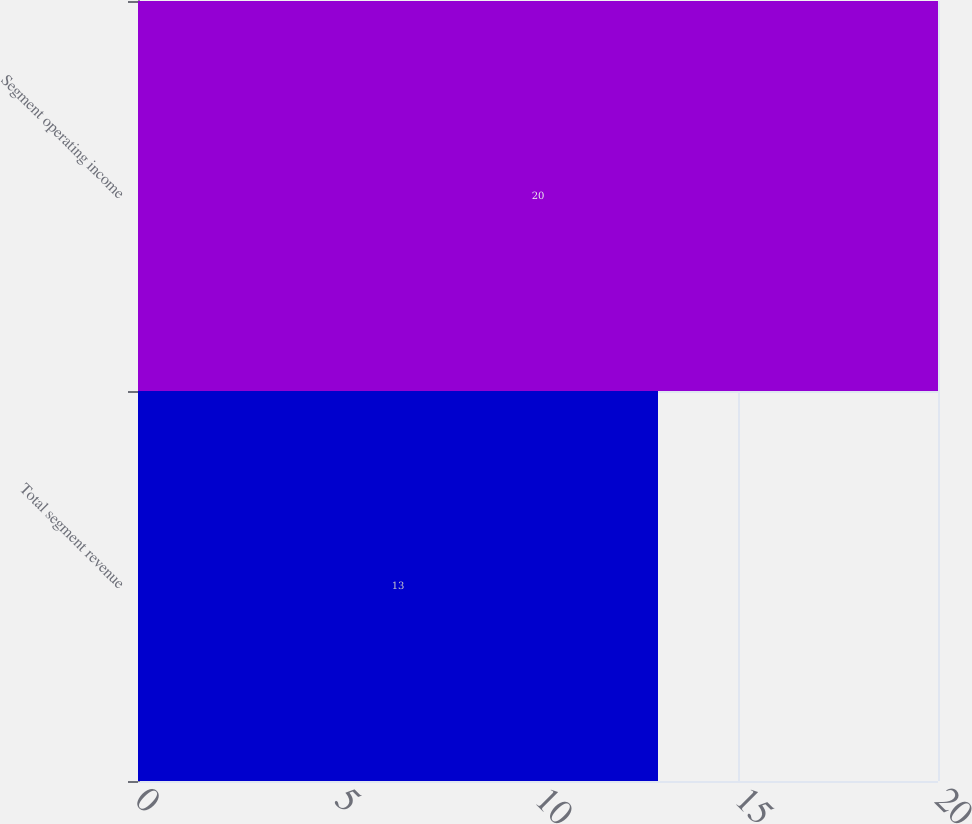Convert chart. <chart><loc_0><loc_0><loc_500><loc_500><bar_chart><fcel>Total segment revenue<fcel>Segment operating income<nl><fcel>13<fcel>20<nl></chart> 